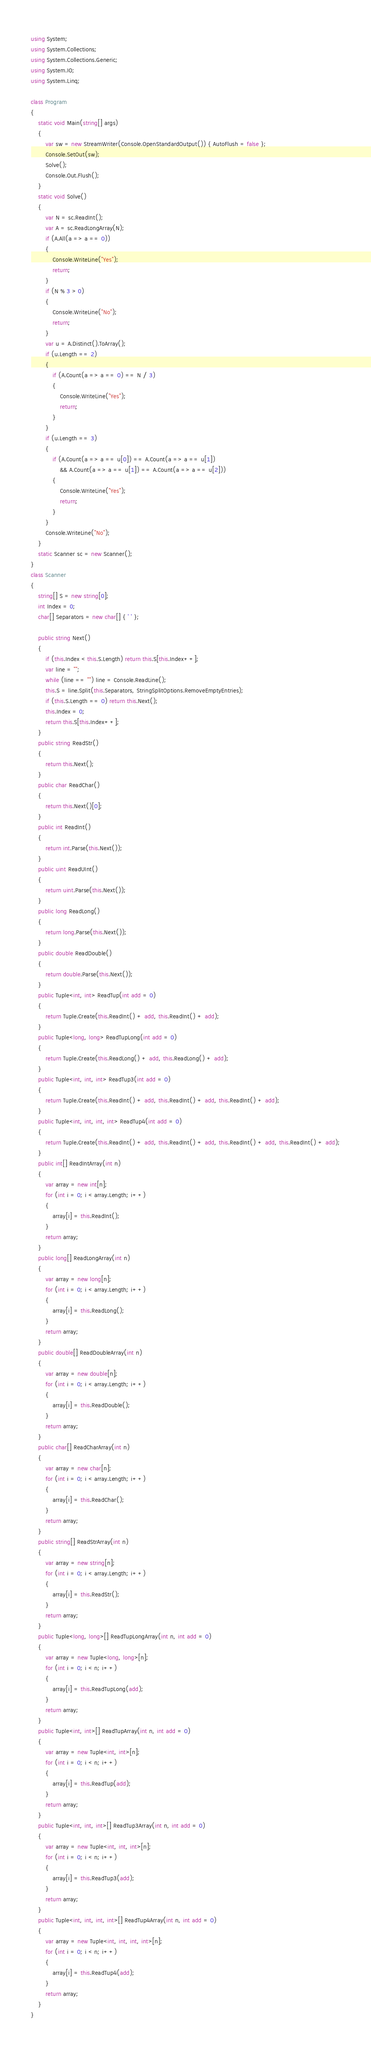Convert code to text. <code><loc_0><loc_0><loc_500><loc_500><_C#_>using System;
using System.Collections;
using System.Collections.Generic;
using System.IO;
using System.Linq;

class Program
{
    static void Main(string[] args)
    {
        var sw = new StreamWriter(Console.OpenStandardOutput()) { AutoFlush = false };
        Console.SetOut(sw);
        Solve();
        Console.Out.Flush();
    }
    static void Solve()
    {
        var N = sc.ReadInt();
        var A = sc.ReadLongArray(N);
        if (A.All(a => a == 0))
        {
            Console.WriteLine("Yes");
            return;
        }
        if (N % 3 > 0)
        {
            Console.WriteLine("No");
            return;
        }
        var u = A.Distinct().ToArray();
        if (u.Length == 2)
        {
            if (A.Count(a => a == 0) == N / 3)
            {
                Console.WriteLine("Yes");
                return;
            }
        }
        if (u.Length == 3)
        {
            if (A.Count(a => a == u[0]) == A.Count(a => a == u[1])
                && A.Count(a => a == u[1]) == A.Count(a => a == u[2]))
            {
                Console.WriteLine("Yes");
                return;
            }
        }
        Console.WriteLine("No");
    }
    static Scanner sc = new Scanner();
}
class Scanner
{
    string[] S = new string[0];
    int Index = 0;
    char[] Separators = new char[] { ' ' };

    public string Next()
    {
        if (this.Index < this.S.Length) return this.S[this.Index++];
        var line = "";
        while (line == "") line = Console.ReadLine();
        this.S = line.Split(this.Separators, StringSplitOptions.RemoveEmptyEntries);
        if (this.S.Length == 0) return this.Next();
        this.Index = 0;
        return this.S[this.Index++];
    }
    public string ReadStr()
    {
        return this.Next();
    }
    public char ReadChar()
    {
        return this.Next()[0];
    }
    public int ReadInt()
    {
        return int.Parse(this.Next());
    }
    public uint ReadUInt()
    {
        return uint.Parse(this.Next());
    }
    public long ReadLong()
    {
        return long.Parse(this.Next());
    }
    public double ReadDouble()
    {
        return double.Parse(this.Next());
    }
    public Tuple<int, int> ReadTup(int add = 0)
    {
        return Tuple.Create(this.ReadInt() + add, this.ReadInt() + add);
    }
    public Tuple<long, long> ReadTupLong(int add = 0)
    {
        return Tuple.Create(this.ReadLong() + add, this.ReadLong() + add);
    }
    public Tuple<int, int, int> ReadTup3(int add = 0)
    {
        return Tuple.Create(this.ReadInt() + add, this.ReadInt() + add, this.ReadInt() + add);
    }
    public Tuple<int, int, int, int> ReadTup4(int add = 0)
    {
        return Tuple.Create(this.ReadInt() + add, this.ReadInt() + add, this.ReadInt() + add, this.ReadInt() + add);
    }
    public int[] ReadIntArray(int n)
    {
        var array = new int[n];
        for (int i = 0; i < array.Length; i++)
        {
            array[i] = this.ReadInt();
        }
        return array;
    }
    public long[] ReadLongArray(int n)
    {
        var array = new long[n];
        for (int i = 0; i < array.Length; i++)
        {
            array[i] = this.ReadLong();
        }
        return array;
    }
    public double[] ReadDoubleArray(int n)
    {
        var array = new double[n];
        for (int i = 0; i < array.Length; i++)
        {
            array[i] = this.ReadDouble();
        }
        return array;
    }
    public char[] ReadCharArray(int n)
    {
        var array = new char[n];
        for (int i = 0; i < array.Length; i++)
        {
            array[i] = this.ReadChar();
        }
        return array;
    }
    public string[] ReadStrArray(int n)
    {
        var array = new string[n];
        for (int i = 0; i < array.Length; i++)
        {
            array[i] = this.ReadStr();
        }
        return array;
    }
    public Tuple<long, long>[] ReadTupLongArray(int n, int add = 0)
    {
        var array = new Tuple<long, long>[n];
        for (int i = 0; i < n; i++)
        {
            array[i] = this.ReadTupLong(add);
        }
        return array;
    }
    public Tuple<int, int>[] ReadTupArray(int n, int add = 0)
    {
        var array = new Tuple<int, int>[n];
        for (int i = 0; i < n; i++)
        {
            array[i] = this.ReadTup(add);
        }
        return array;
    }
    public Tuple<int, int, int>[] ReadTup3Array(int n, int add = 0)
    {
        var array = new Tuple<int, int, int>[n];
        for (int i = 0; i < n; i++)
        {
            array[i] = this.ReadTup3(add);
        }
        return array;
    }
    public Tuple<int, int, int, int>[] ReadTup4Array(int n, int add = 0)
    {
        var array = new Tuple<int, int, int, int>[n];
        for (int i = 0; i < n; i++)
        {
            array[i] = this.ReadTup4(add);
        }
        return array;
    }
}
</code> 